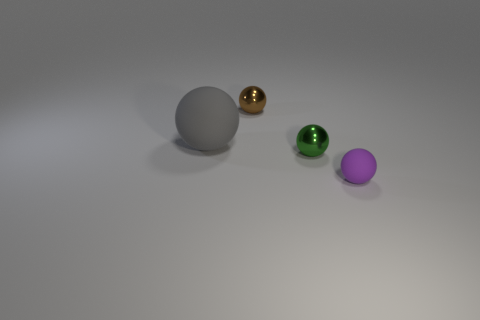Is the shape of the rubber thing right of the gray rubber thing the same as  the gray matte object?
Ensure brevity in your answer.  Yes. The green metallic object has what shape?
Provide a short and direct response. Sphere. How many purple objects are made of the same material as the big ball?
Your answer should be very brief. 1. Is the color of the large matte thing the same as the metallic object that is to the left of the tiny green metal object?
Offer a very short reply. No. What number of brown matte spheres are there?
Your answer should be compact. 0. Are there any small shiny spheres that have the same color as the large matte ball?
Ensure brevity in your answer.  No. There is a rubber object that is on the left side of the sphere that is in front of the tiny metallic sphere that is in front of the small brown metallic thing; what color is it?
Offer a terse response. Gray. Is the purple object made of the same material as the gray sphere that is behind the small green metallic sphere?
Offer a very short reply. Yes. What is the material of the purple sphere?
Ensure brevity in your answer.  Rubber. How many other objects are the same material as the small purple ball?
Offer a terse response. 1. 